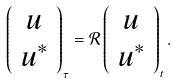Convert formula to latex. <formula><loc_0><loc_0><loc_500><loc_500>\left ( \begin{array} { c } u \\ u ^ { * } \end{array} \right ) _ { \tau } = \mathcal { R } \left ( \begin{array} { c } u \\ u ^ { * } \end{array} \right ) _ { t } .</formula> 